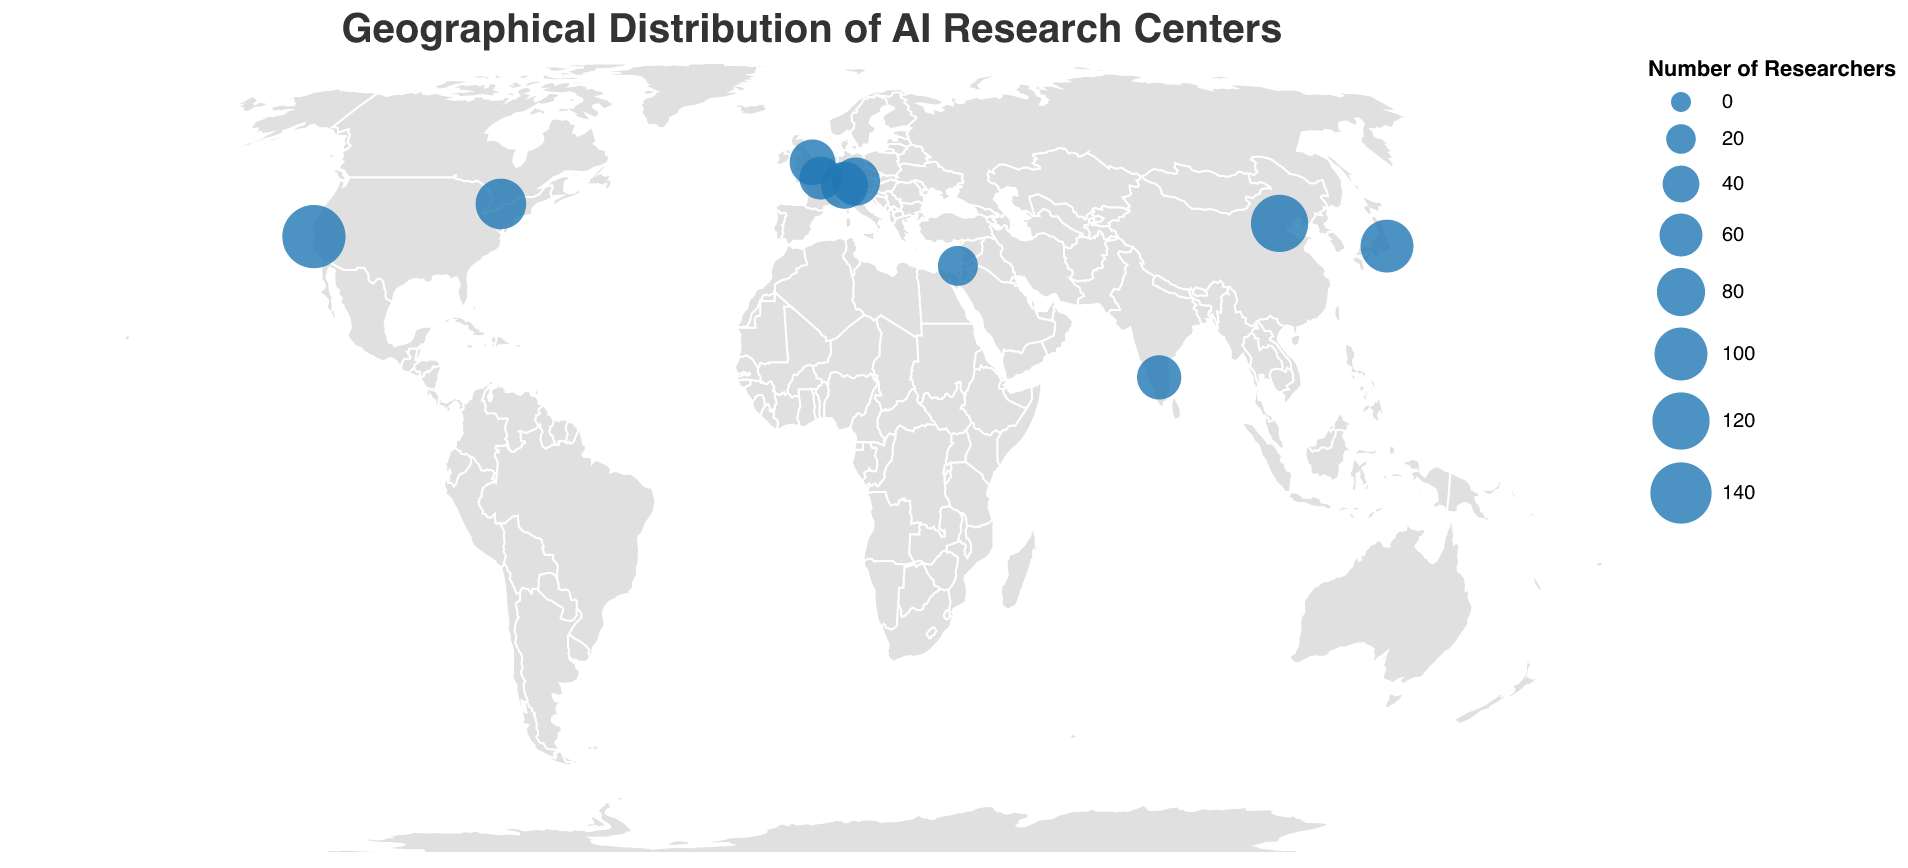What's the title of the figure? The title is prominently displayed at the top center of the figure.
Answer: Geographical Distribution of AI Research Centers How many research centers are displayed on the map? By counting the number of circles representing research centers on the map, we find there are ten such centers.
Answer: 10 Which city has the highest number of researchers? By looking at the size of the circles and the tooltip data, the largest circle corresponds to Stanford AI Lab in Silicon Valley, which has 150 researchers.
Answer: Silicon Valley Which cities have a research center specializing in "Facial Recognition" and "Visual Question Answering"? Use the tooltip information to identify that "Facial Recognition" is specialized in Beijing and "Visual Question Answering" in Bangalore.
Answer: Beijing and Bangalore Which research center is located in Paris? By examining the tooltip data for the circle near Paris, we find the research center is INRIA-WILLOW.
Answer: INRIA-WILLOW Compare the number of researchers in Zurich and Cambridge. Which one has more researchers and by how much? Zurich has 75 researchers, and Cambridge has 70 researchers. The difference is 75 - 70 = 5.
Answer: Zurich has 5 more researchers What is the average number of researchers across all research centers? Summing up all researchers: 150 + 120 + 80 + 70 + 100 + 90 + 60 + 50 + 75 + 65 = 860. Divide by the number of research centers: 860 / 10 = 86.
Answer: 86 From which different continents are the research centers? The figure shows research centers in North America, Asia, Europe, and the Middle East as indicated by the circles in USA, China, Japan, Canada, Germany, UK, France, Switzerland, Israel, and India.
Answer: North America, Asia, Europe, Middle East Identify the specialization of the research center with the smallest number of researchers. The smallest circle corresponds to AI21 Labs in Tel Aviv with 50 researchers specializing in "Natural Language to Image Generation".
Answer: Natural Language to Image Generation Which countries have more than one research center represented on the map? From the data, no country has more than one research center on the map.
Answer: None 